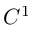Convert formula to latex. <formula><loc_0><loc_0><loc_500><loc_500>C ^ { 1 }</formula> 